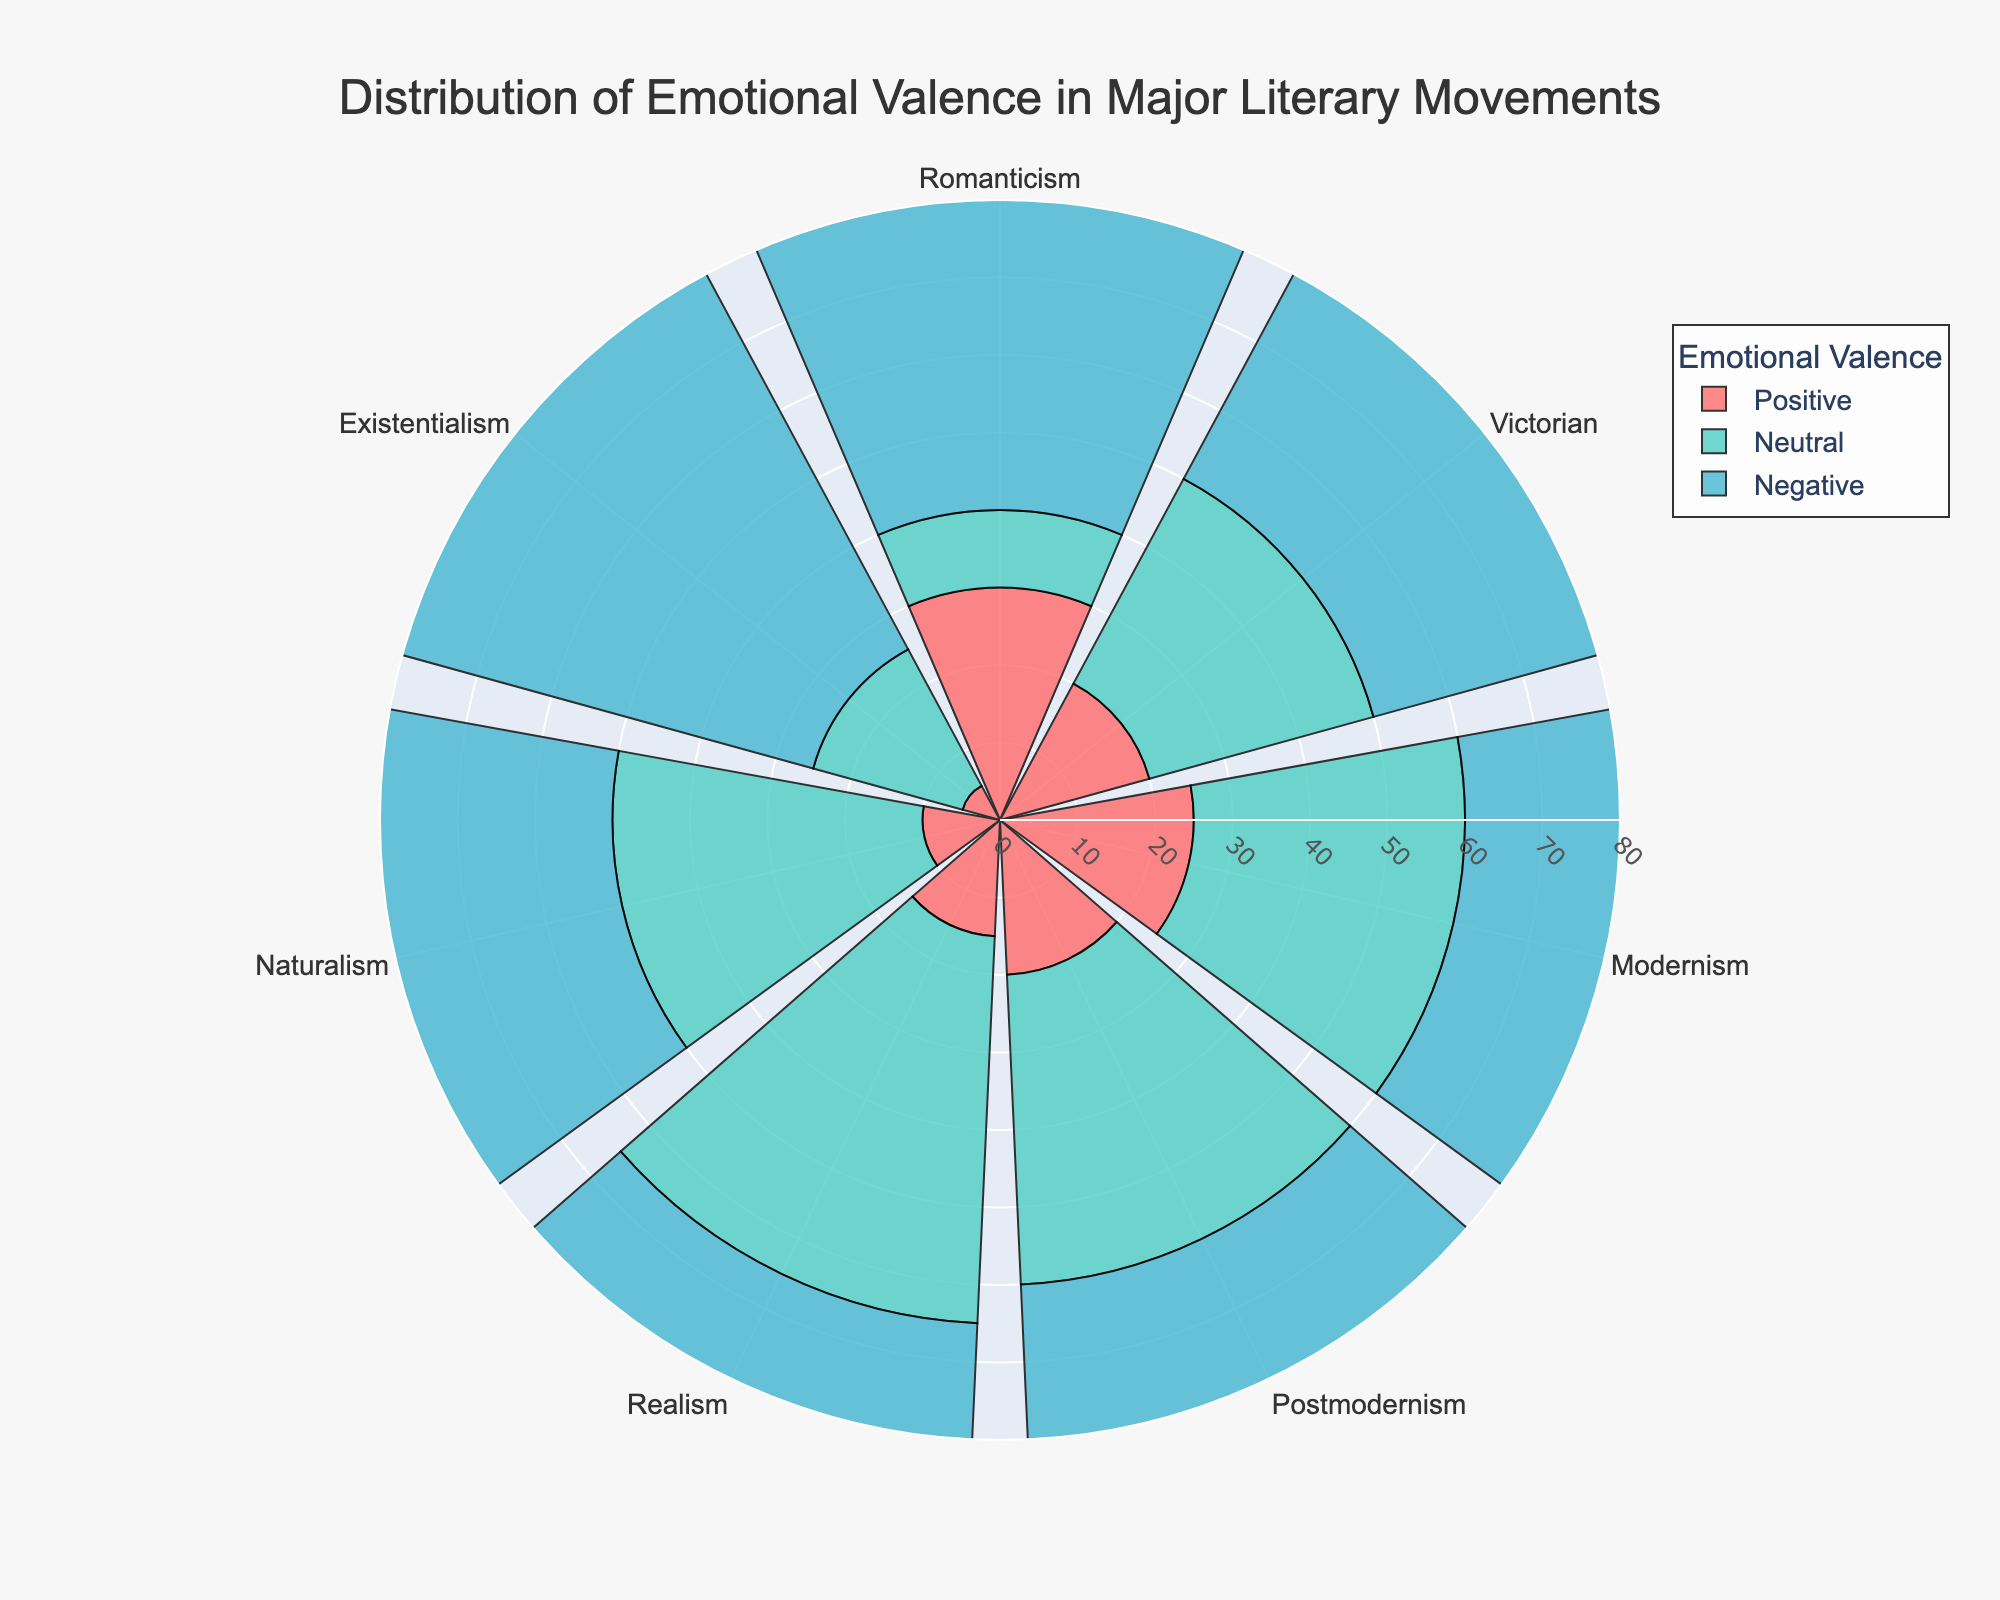Which literary movement has the highest proportion of negative emotions? By looking at the chart, the Existentialism segment has the longest bar for negative emotions compared to other movements.
Answer: Existentialism How many literary movements have a higher proportion of neutral emotions than positive emotions? Observing the chart, Victorian, Modernism, Postmodernism, Realism, and Naturalism all have longer bars for neutral emotions compared to positive emotions.
Answer: 5 What's the total number of positive emotions in Romanticism and Victorian combined? Adding the values for Romanticism (30) and Victorian (20), we get 30 + 20 = 50
Answer: 50 Which literary movement has the least positive emotions? By comparing the length of the bars for positive emotions among all the movements, Existentialism has the shortest bar for positive emotions.
Answer: Existentialism What is the difference in negative emotions between Naturalism and Realism? Subtracting the value of negative emotions in Realism (35) from the value in Naturalism (50), we get 50 - 35 = 15.
Answer: 15 Arrange the literary movements in ascending order of neutral emotions. From the chart, we can rank the movements based on their neutral emotion bars: Romanticism (10), Existentialism (20), Victorian (30), Naturalism (40), Modernism (35), Postmodernism (40), Realism (50).
Answer: Romanticism, Existentialism, Victorian, Modernism, Naturalism, Postmodernism, Realism Which literary movement has an equal proportion of neutral and negative emotions? Observing the chart, Postmodernism has equal lengths of bars for both neutral and negative emotions (40 each).
Answer: Postmodernism What is the average proportion of negative emotions across all literary movements? Summing the values for negative emotions (60 + 50 + 40 + 40 + 35 + 50 + 75) = 350, and then dividing by the number of literary movements (7), 350 / 7 = 50
Answer: 50 In which literary movement is the combined total of positive and neutral emotions less than the negative emotions? Adding the positive and neutral values for all movements, then comparing to negative values: Existentialism (5 + 20 < 75) is the one where this is true.
Answer: Existentialism 